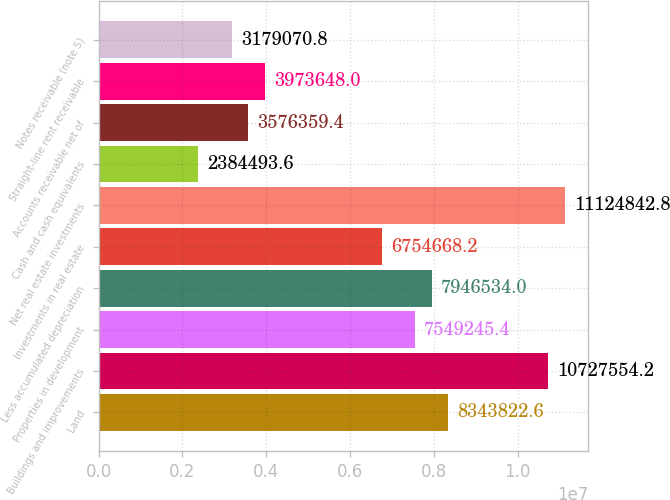Convert chart to OTSL. <chart><loc_0><loc_0><loc_500><loc_500><bar_chart><fcel>Land<fcel>Buildings and improvements<fcel>Properties in development<fcel>Less accumulated depreciation<fcel>Investments in real estate<fcel>Net real estate investments<fcel>Cash and cash equivalents<fcel>Accounts receivable net of<fcel>Straight-line rent receivable<fcel>Notes receivable (note 5)<nl><fcel>8.34382e+06<fcel>1.07276e+07<fcel>7.54925e+06<fcel>7.94653e+06<fcel>6.75467e+06<fcel>1.11248e+07<fcel>2.38449e+06<fcel>3.57636e+06<fcel>3.97365e+06<fcel>3.17907e+06<nl></chart> 